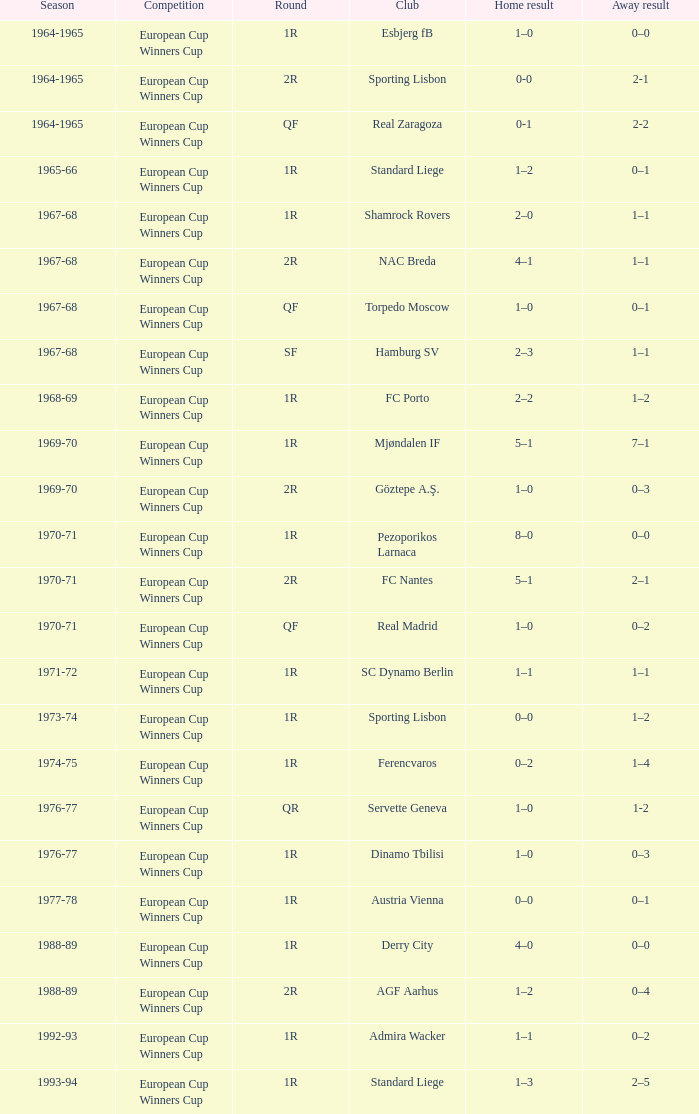In a 2r round with a 0-0 home outcome, which season does it belong to? 1964-1965. 